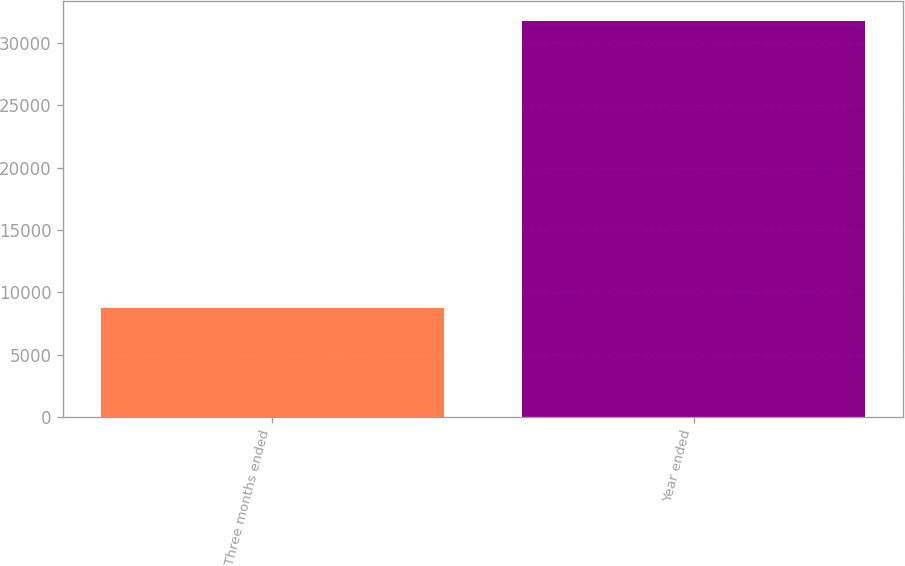Convert chart to OTSL. <chart><loc_0><loc_0><loc_500><loc_500><bar_chart><fcel>Three months ended<fcel>Year ended<nl><fcel>8722<fcel>31759<nl></chart> 